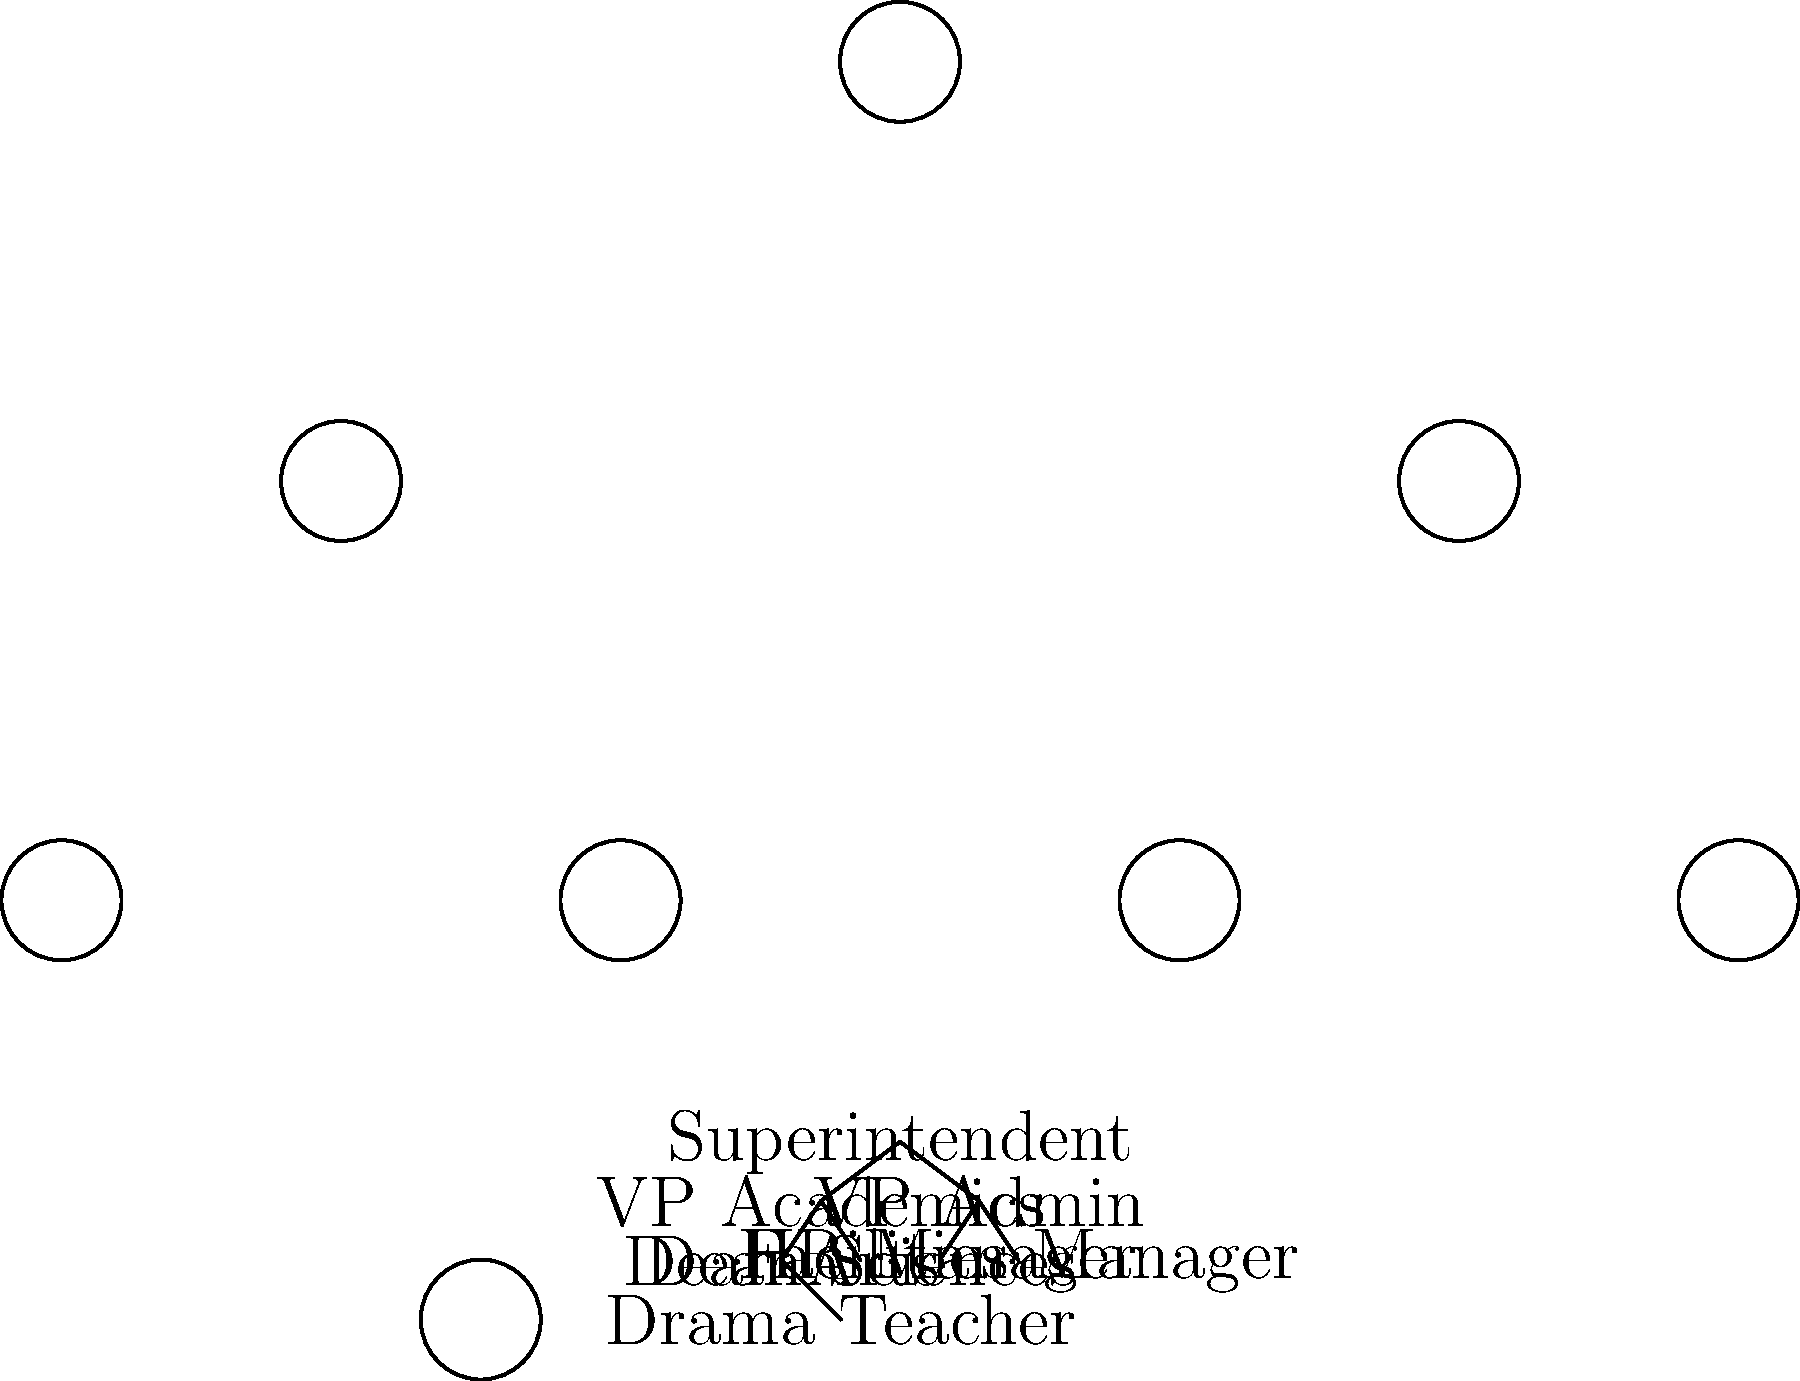As a school administrator who appreciates innovative teaching methods, you're reviewing the school's organizational structure. In the given tree topology representing the school's hierarchy, what is the minimum number of levels (or hops) between the Drama Teacher and the Superintendent? To determine the minimum number of levels (or hops) between the Drama Teacher and the Superintendent, we need to follow these steps:

1. Identify the positions of the Drama Teacher and Superintendent in the hierarchy:
   - The Superintendent is at the top (root) of the tree.
   - The Drama Teacher is at the bottom level of the tree.

2. Count the levels between them:
   - Level 0: Superintendent
   - Level 1: VP Academics
   - Level 2: Dean Arts
   - Level 3: Drama Teacher

3. Calculate the number of hops:
   - The number of hops is equal to the number of edges traversed between the two positions.
   - In this case, we traverse 3 edges: 
     Superintendent → VP Academics → Dean Arts → Drama Teacher

4. Conclusion:
   The minimum number of levels (or hops) between the Drama Teacher and the Superintendent is 3.

This tree topology illustrates how innovative teaching methods, like those employed by the Drama Teacher, can be supported through a clear organizational structure. The relatively short path (3 hops) between the Drama Teacher and the Superintendent suggests a potential for efficient communication and support for creative educational approaches.
Answer: 3 